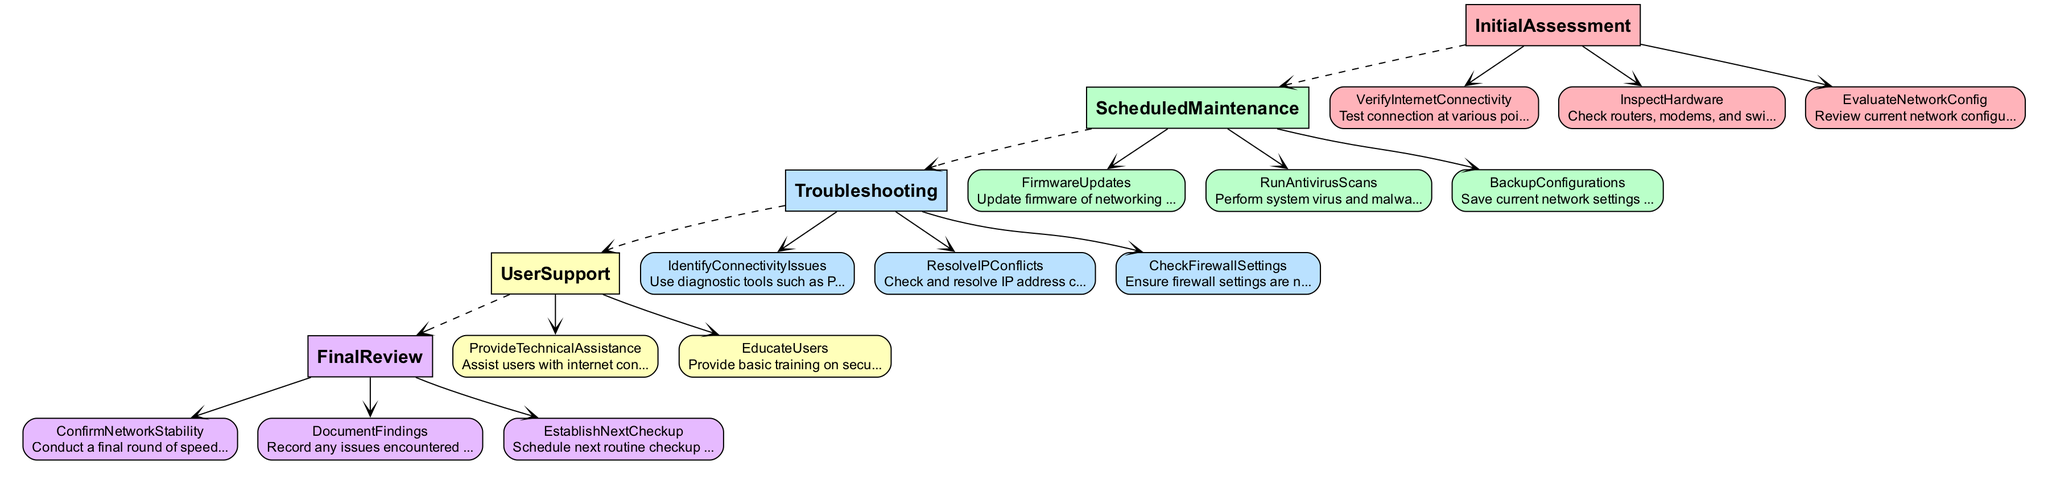What are the three main categories of the checklist? The diagram indicates that the checklist is divided into three main categories: Initial Assessment, Scheduled Maintenance, Troubleshooting, User Support, and Final Review. Count them and list the distinct categories present in the diagram.
Answer: Initial Assessment, Scheduled Maintenance, Troubleshooting, User Support, Final Review What is the first task in the Initial Assessment category? Referring to the diagram, identify the first subtask listed under the 'Initial Assessment' category by locating the first node under that section.
Answer: Verify Internet Connectivity How many tasks are listed under the User Support category? To answer this question, count the number of sub-tasks within the 'User Support' category as represented in the diagram.
Answer: Two Which task follows the Firmware Updates step? By examining the edges connecting the nodes, determine which task is directly connected after 'Firmware Updates' within the 'Scheduled Maintenance' category.
Answer: Run Antivirus Scans What is the last task to be completed in the Final Review category? Check the order of the tasks in the 'Final Review' category and identify the last task listed before completion, following the flow of tasks as depicted in the diagram.
Answer: Establish Next Checkup How many total nodes are there in the diagram? Add the number of main categories and their respective sub-tasks as depicted in the diagram, which collectively represent the nodes present.
Answer: Twenty What diagnostic tool is suggested for identifying connectivity issues? Review the 'Troubleshooting' category in the diagram and identify the specific diagnostic tool mentioned for this purpose.
Answer: PingPlotter What must be backed up in the Scheduled Maintenance phase? Look at the specific task under 'Scheduled Maintenance' that pertains to saving current network settings and configurations, then summarize that information from the diagram.
Answer: Backup Configurations Which task requires educating users about secure practices? Find the specific task within the 'User Support' category that focuses on training users in safe internet practices and summarize the task as represented in the diagram.
Answer: Educate Users 